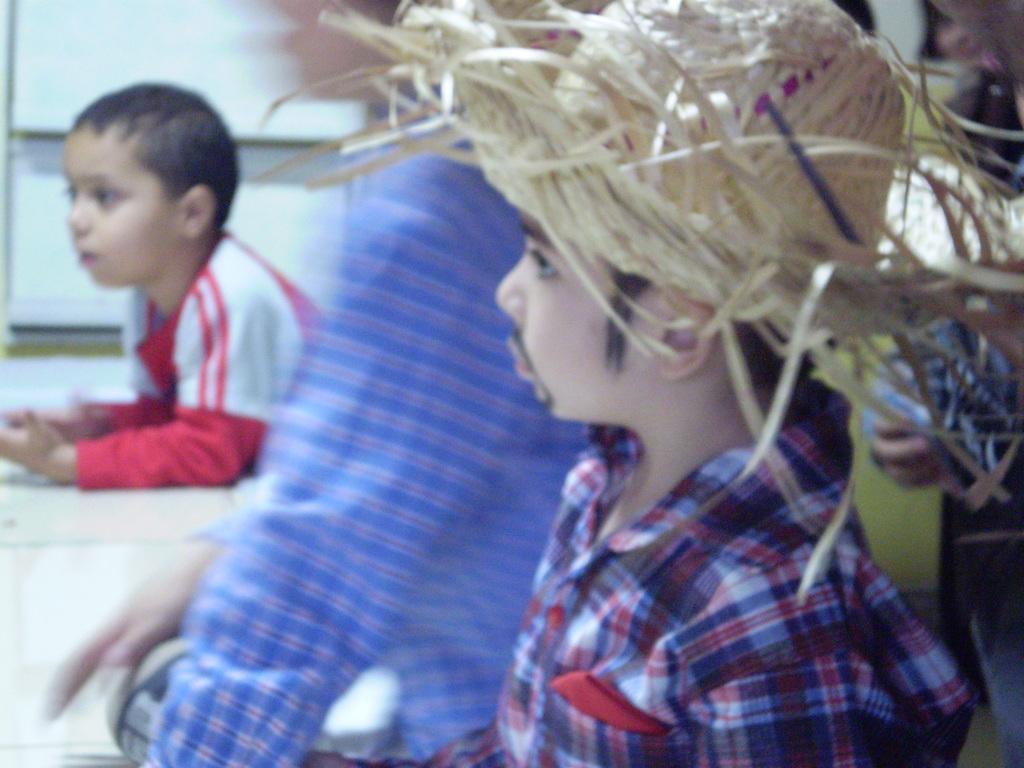Please provide a concise description of this image. In the given picture, we can see some people and white color board. 